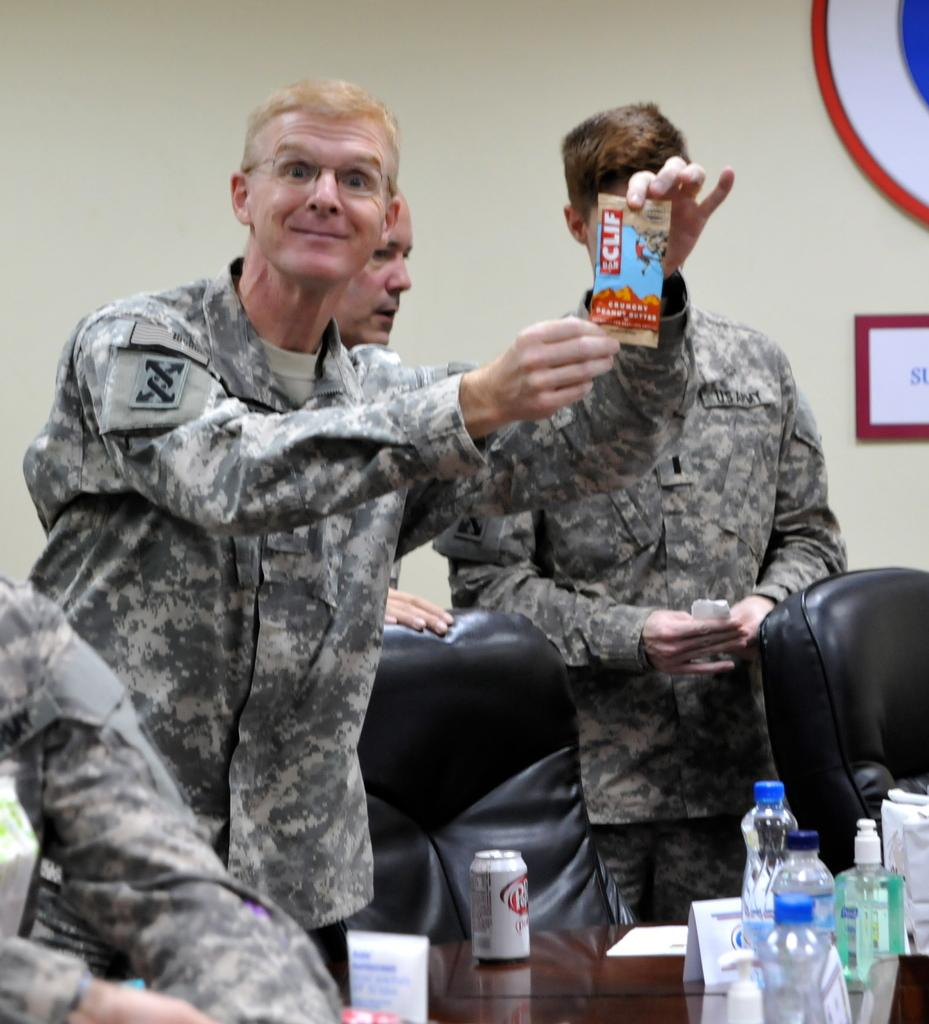What is happening in the image? There are people standing in front of a table, and there is a pet on the table. What else can be seen on the table? There are bottles on the table. Can you describe the background of the image? There is a bowl visible behind the people. What is the person at the center holding? The person at the center is holding a sachet with "clef" written on it. Can you see any ghosts in the image? There are no ghosts present in the image. What type of jellyfish is swimming in the bowl behind the people? There is no jellyfish in the bowl; it contains an unspecified item. 